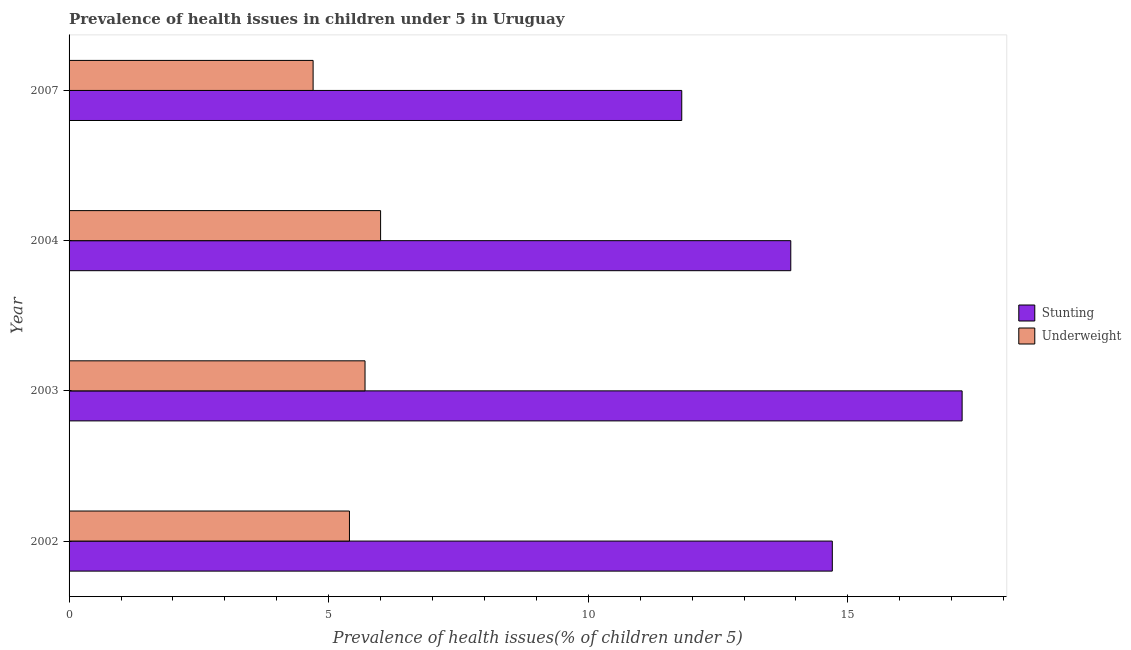How many different coloured bars are there?
Your answer should be very brief. 2. Are the number of bars on each tick of the Y-axis equal?
Offer a terse response. Yes. How many bars are there on the 1st tick from the top?
Your answer should be very brief. 2. What is the label of the 4th group of bars from the top?
Your response must be concise. 2002. What is the percentage of underweight children in 2003?
Offer a very short reply. 5.7. Across all years, what is the maximum percentage of stunted children?
Keep it short and to the point. 17.2. Across all years, what is the minimum percentage of underweight children?
Keep it short and to the point. 4.7. What is the total percentage of underweight children in the graph?
Make the answer very short. 21.8. What is the difference between the percentage of underweight children in 2003 and that in 2004?
Provide a succinct answer. -0.3. What is the difference between the percentage of underweight children in 2004 and the percentage of stunted children in 2003?
Your response must be concise. -11.2. What is the average percentage of underweight children per year?
Offer a very short reply. 5.45. In the year 2003, what is the difference between the percentage of underweight children and percentage of stunted children?
Offer a terse response. -11.5. In how many years, is the percentage of underweight children greater than 15 %?
Your answer should be compact. 0. What is the difference between the highest and the second highest percentage of stunted children?
Offer a terse response. 2.5. What is the difference between the highest and the lowest percentage of underweight children?
Keep it short and to the point. 1.3. In how many years, is the percentage of underweight children greater than the average percentage of underweight children taken over all years?
Provide a succinct answer. 2. Is the sum of the percentage of stunted children in 2002 and 2007 greater than the maximum percentage of underweight children across all years?
Offer a terse response. Yes. What does the 1st bar from the top in 2004 represents?
Provide a short and direct response. Underweight. What does the 2nd bar from the bottom in 2007 represents?
Give a very brief answer. Underweight. How many bars are there?
Ensure brevity in your answer.  8. How many legend labels are there?
Keep it short and to the point. 2. What is the title of the graph?
Make the answer very short. Prevalence of health issues in children under 5 in Uruguay. What is the label or title of the X-axis?
Give a very brief answer. Prevalence of health issues(% of children under 5). What is the Prevalence of health issues(% of children under 5) in Stunting in 2002?
Give a very brief answer. 14.7. What is the Prevalence of health issues(% of children under 5) in Underweight in 2002?
Keep it short and to the point. 5.4. What is the Prevalence of health issues(% of children under 5) in Stunting in 2003?
Offer a very short reply. 17.2. What is the Prevalence of health issues(% of children under 5) in Underweight in 2003?
Offer a terse response. 5.7. What is the Prevalence of health issues(% of children under 5) of Stunting in 2004?
Give a very brief answer. 13.9. What is the Prevalence of health issues(% of children under 5) of Underweight in 2004?
Offer a terse response. 6. What is the Prevalence of health issues(% of children under 5) in Stunting in 2007?
Your answer should be compact. 11.8. What is the Prevalence of health issues(% of children under 5) in Underweight in 2007?
Your answer should be compact. 4.7. Across all years, what is the maximum Prevalence of health issues(% of children under 5) in Stunting?
Give a very brief answer. 17.2. Across all years, what is the minimum Prevalence of health issues(% of children under 5) in Stunting?
Ensure brevity in your answer.  11.8. Across all years, what is the minimum Prevalence of health issues(% of children under 5) of Underweight?
Ensure brevity in your answer.  4.7. What is the total Prevalence of health issues(% of children under 5) in Stunting in the graph?
Give a very brief answer. 57.6. What is the total Prevalence of health issues(% of children under 5) of Underweight in the graph?
Your answer should be very brief. 21.8. What is the difference between the Prevalence of health issues(% of children under 5) in Stunting in 2002 and that in 2004?
Ensure brevity in your answer.  0.8. What is the difference between the Prevalence of health issues(% of children under 5) of Stunting in 2002 and that in 2007?
Your response must be concise. 2.9. What is the difference between the Prevalence of health issues(% of children under 5) in Underweight in 2003 and that in 2004?
Keep it short and to the point. -0.3. What is the difference between the Prevalence of health issues(% of children under 5) in Stunting in 2003 and that in 2007?
Offer a terse response. 5.4. What is the difference between the Prevalence of health issues(% of children under 5) in Underweight in 2003 and that in 2007?
Provide a short and direct response. 1. What is the difference between the Prevalence of health issues(% of children under 5) in Stunting in 2004 and that in 2007?
Provide a short and direct response. 2.1. What is the difference between the Prevalence of health issues(% of children under 5) of Stunting in 2002 and the Prevalence of health issues(% of children under 5) of Underweight in 2004?
Your answer should be compact. 8.7. What is the difference between the Prevalence of health issues(% of children under 5) in Stunting in 2003 and the Prevalence of health issues(% of children under 5) in Underweight in 2007?
Ensure brevity in your answer.  12.5. What is the difference between the Prevalence of health issues(% of children under 5) in Stunting in 2004 and the Prevalence of health issues(% of children under 5) in Underweight in 2007?
Your answer should be compact. 9.2. What is the average Prevalence of health issues(% of children under 5) of Stunting per year?
Provide a short and direct response. 14.4. What is the average Prevalence of health issues(% of children under 5) of Underweight per year?
Keep it short and to the point. 5.45. What is the ratio of the Prevalence of health issues(% of children under 5) in Stunting in 2002 to that in 2003?
Your response must be concise. 0.85. What is the ratio of the Prevalence of health issues(% of children under 5) of Stunting in 2002 to that in 2004?
Your answer should be compact. 1.06. What is the ratio of the Prevalence of health issues(% of children under 5) in Underweight in 2002 to that in 2004?
Offer a very short reply. 0.9. What is the ratio of the Prevalence of health issues(% of children under 5) in Stunting in 2002 to that in 2007?
Make the answer very short. 1.25. What is the ratio of the Prevalence of health issues(% of children under 5) in Underweight in 2002 to that in 2007?
Provide a short and direct response. 1.15. What is the ratio of the Prevalence of health issues(% of children under 5) in Stunting in 2003 to that in 2004?
Keep it short and to the point. 1.24. What is the ratio of the Prevalence of health issues(% of children under 5) in Stunting in 2003 to that in 2007?
Offer a terse response. 1.46. What is the ratio of the Prevalence of health issues(% of children under 5) in Underweight in 2003 to that in 2007?
Make the answer very short. 1.21. What is the ratio of the Prevalence of health issues(% of children under 5) of Stunting in 2004 to that in 2007?
Provide a succinct answer. 1.18. What is the ratio of the Prevalence of health issues(% of children under 5) in Underweight in 2004 to that in 2007?
Offer a terse response. 1.28. What is the difference between the highest and the second highest Prevalence of health issues(% of children under 5) in Stunting?
Ensure brevity in your answer.  2.5. What is the difference between the highest and the second highest Prevalence of health issues(% of children under 5) of Underweight?
Keep it short and to the point. 0.3. 